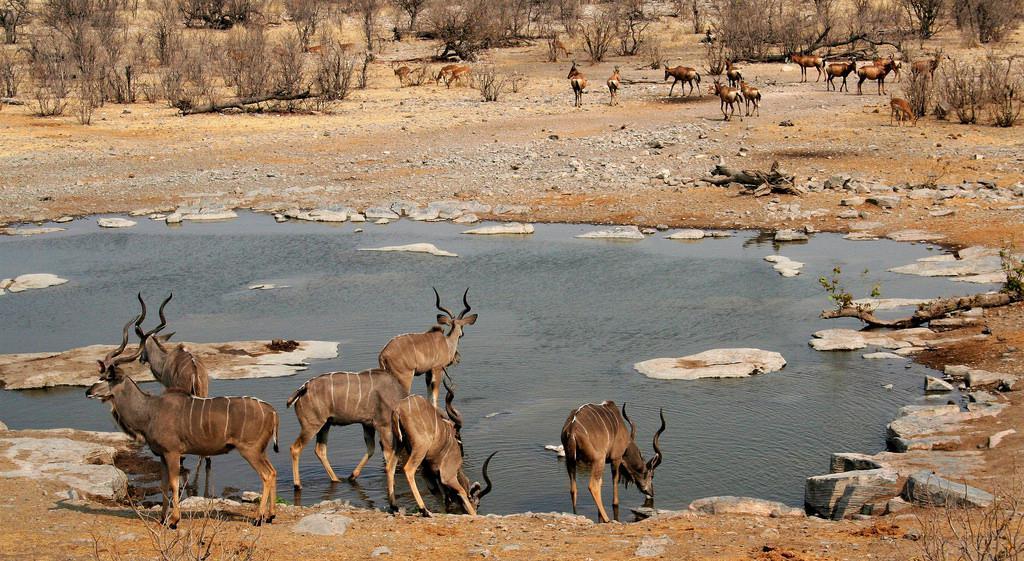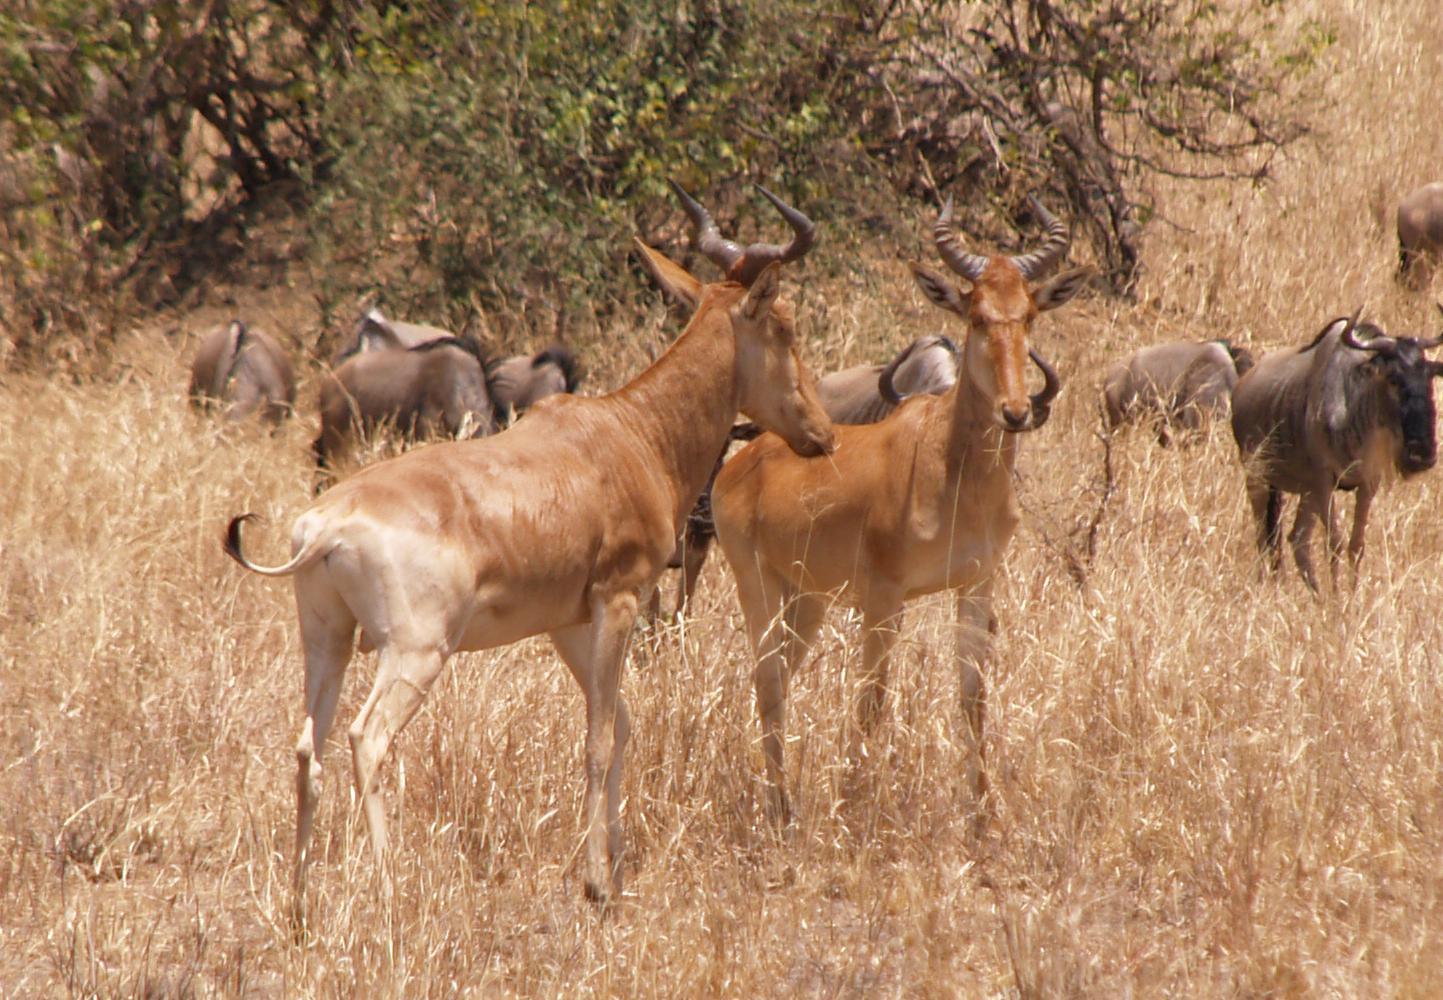The first image is the image on the left, the second image is the image on the right. Given the left and right images, does the statement "An image includes multiple zebra and at least one brown horned animal." hold true? Answer yes or no. No. The first image is the image on the left, the second image is the image on the right. For the images displayed, is the sentence "Zebras are near the horned animals in the image on the right." factually correct? Answer yes or no. No. 